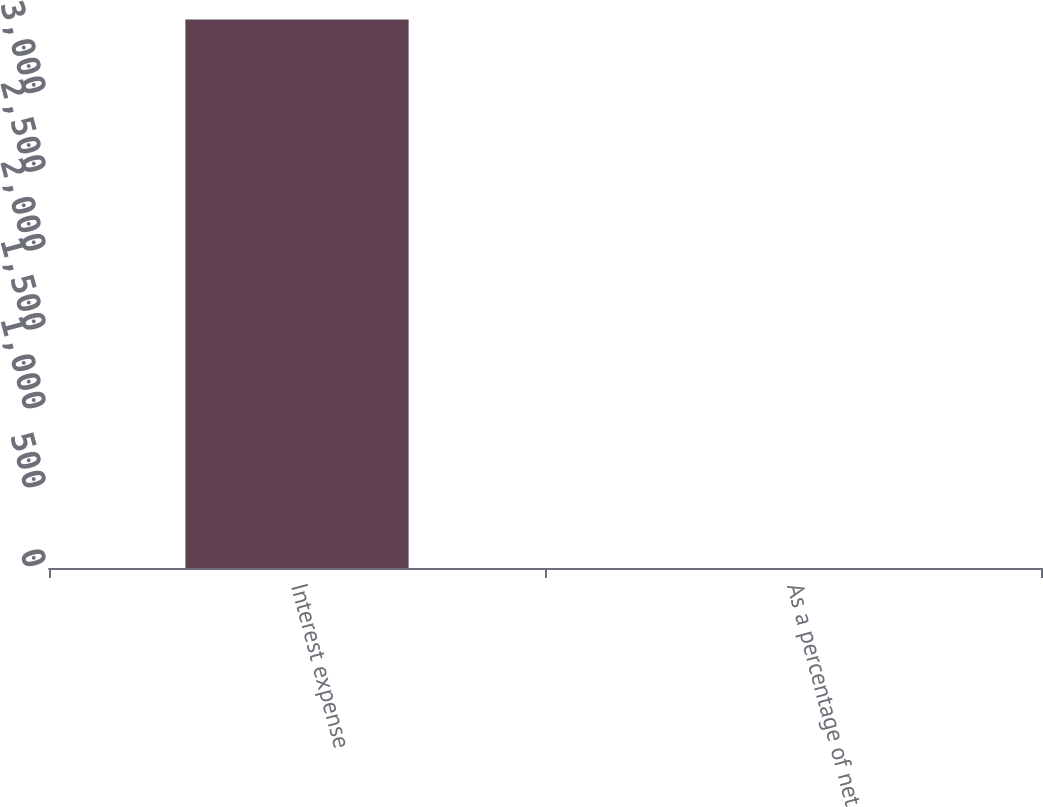Convert chart to OTSL. <chart><loc_0><loc_0><loc_500><loc_500><bar_chart><fcel>Interest expense<fcel>As a percentage of net<nl><fcel>3478<fcel>0.1<nl></chart> 